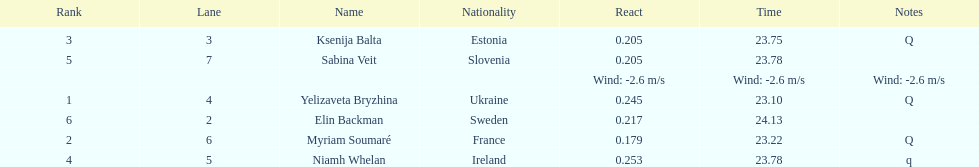The first person to finish in heat 1? Yelizaveta Bryzhina. 